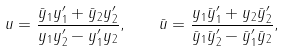Convert formula to latex. <formula><loc_0><loc_0><loc_500><loc_500>u = \frac { \bar { y } _ { 1 } y _ { 1 } ^ { \prime } + \bar { y } _ { 2 } y _ { 2 } ^ { \prime } } { y _ { 1 } y _ { 2 } ^ { \prime } - y _ { 1 } ^ { \prime } y _ { 2 } } , \quad \bar { u } = \frac { y _ { 1 } \bar { y } _ { 1 } ^ { \prime } + y _ { 2 } \bar { y } _ { 2 } ^ { \prime } } { \bar { y } _ { 1 } \bar { y } _ { 2 } ^ { \prime } - \bar { y } _ { 1 } ^ { \prime } \bar { y } _ { 2 } } ,</formula> 